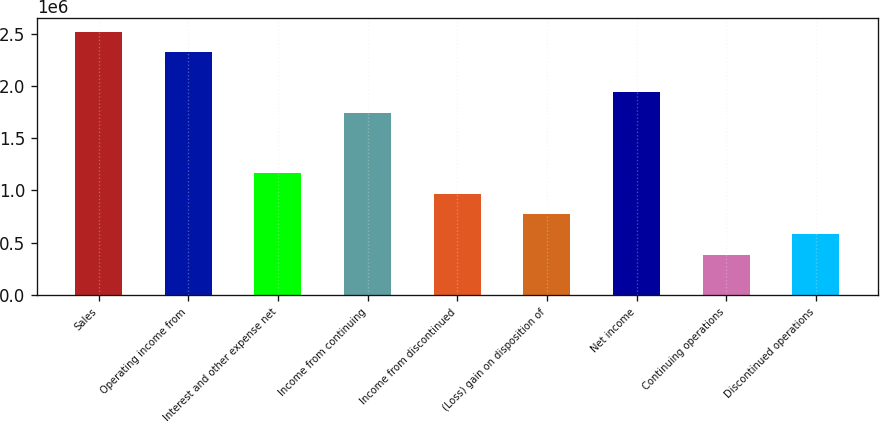Convert chart to OTSL. <chart><loc_0><loc_0><loc_500><loc_500><bar_chart><fcel>Sales<fcel>Operating income from<fcel>Interest and other expense net<fcel>Income from continuing<fcel>Income from discontinued<fcel>(Loss) gain on disposition of<fcel>Net income<fcel>Continuing operations<fcel>Discontinued operations<nl><fcel>2.5187e+06<fcel>2.32496e+06<fcel>1.16248e+06<fcel>1.74372e+06<fcel>968733<fcel>774986<fcel>1.93746e+06<fcel>387493<fcel>581240<nl></chart> 